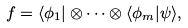Convert formula to latex. <formula><loc_0><loc_0><loc_500><loc_500>f = \langle \phi _ { 1 } | \otimes \dots \otimes \langle \phi _ { m } | \psi \rangle ,</formula> 